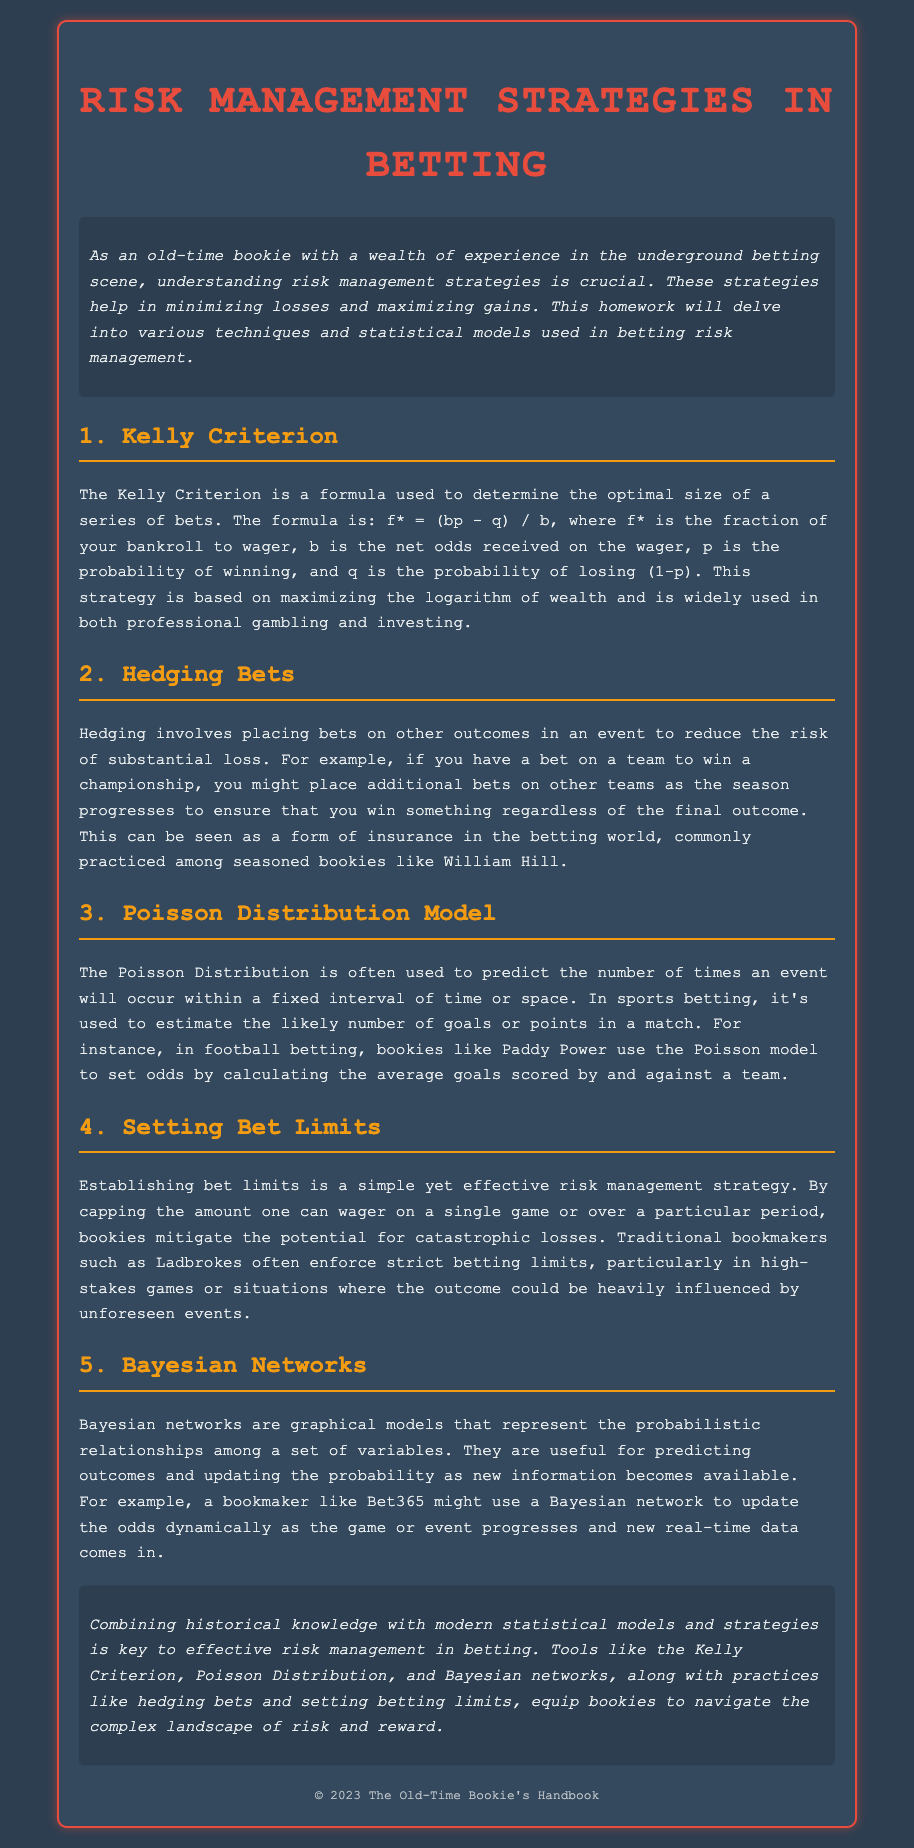What is the formula for the Kelly Criterion? The Kelly Criterion formula is used to determine the optimal size of a series of bets, represented as f* = (bp - q) / b.
Answer: f* = (bp - q) / b What does hedging involve? Hedging involves placing bets on other outcomes in an event to reduce the risk of substantial loss.
Answer: Placing bets on other outcomes What statistical model is mentioned for predicting events in betting? The document mentions the Poisson Distribution model for predicting the number of goals or points in a match.
Answer: Poisson Distribution What is the purpose of setting bet limits? Establishing bet limits caps the amount one can wager, mitigating the potential for catastrophic losses.
Answer: Mitigating catastrophic losses Which model updates probabilities as new information becomes available? Bayesian networks are graphical models used to represent probabilistic relationships and update probabilities.
Answer: Bayesian networks 